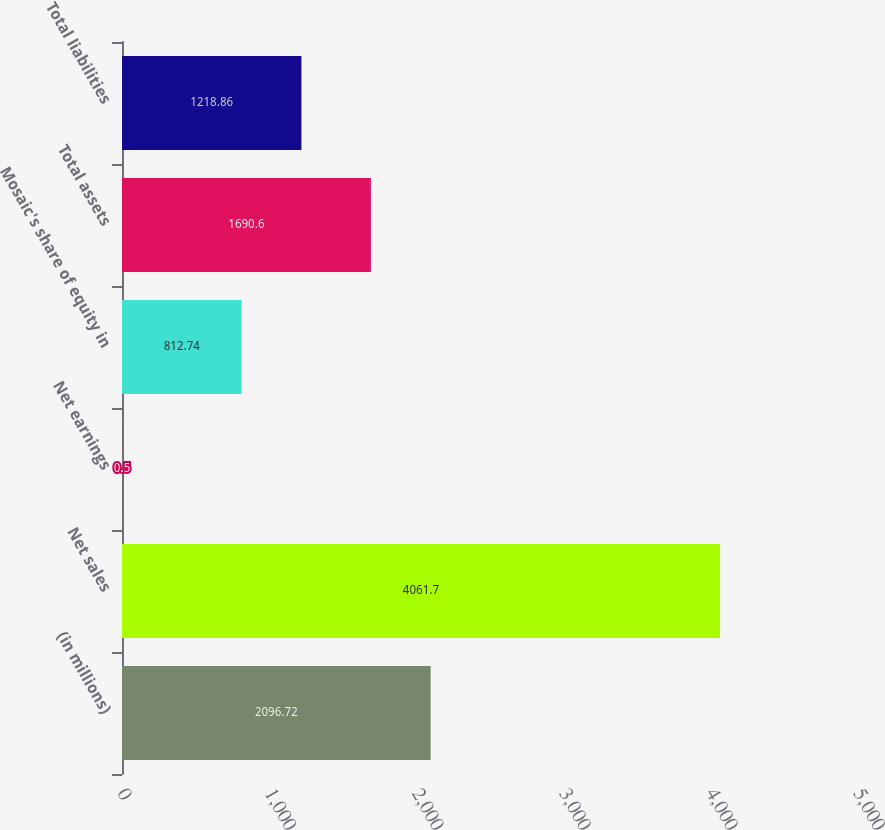Convert chart to OTSL. <chart><loc_0><loc_0><loc_500><loc_500><bar_chart><fcel>(in millions)<fcel>Net sales<fcel>Net earnings<fcel>Mosaic's share of equity in<fcel>Total assets<fcel>Total liabilities<nl><fcel>2096.72<fcel>4061.7<fcel>0.5<fcel>812.74<fcel>1690.6<fcel>1218.86<nl></chart> 